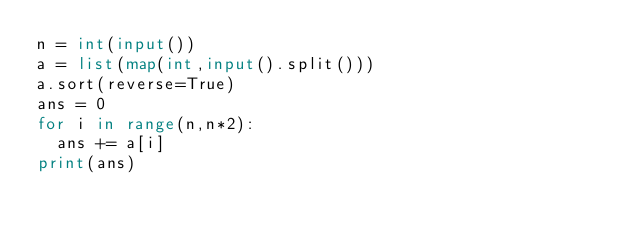<code> <loc_0><loc_0><loc_500><loc_500><_Python_>n = int(input())
a = list(map(int,input().split()))
a.sort(reverse=True)
ans = 0
for i in range(n,n*2):
  ans += a[i]
print(ans)</code> 